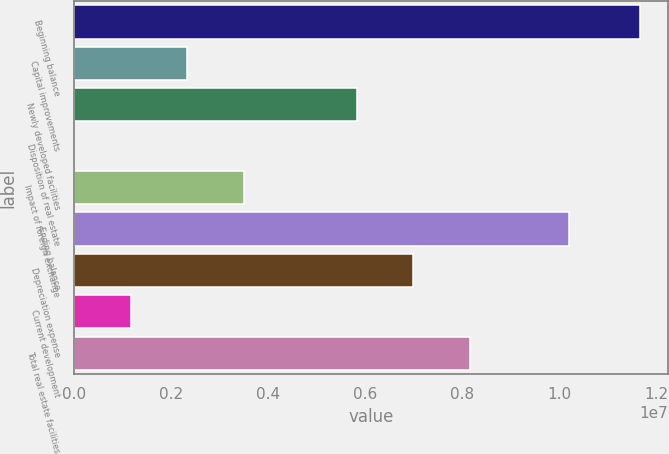<chart> <loc_0><loc_0><loc_500><loc_500><bar_chart><fcel>Beginning balance<fcel>Capital improvements<fcel>Newly developed facilities<fcel>Disposition of real estate<fcel>Impact of foreign exchange<fcel>Ending balance<fcel>Depreciation expense<fcel>Current development<fcel>Total real estate facilities<nl><fcel>1.16588e+07<fcel>2.33298e+06<fcel>5.83016e+06<fcel>1522<fcel>3.49871e+06<fcel>1.0207e+07<fcel>6.99589e+06<fcel>1.16725e+06<fcel>8.16162e+06<nl></chart> 